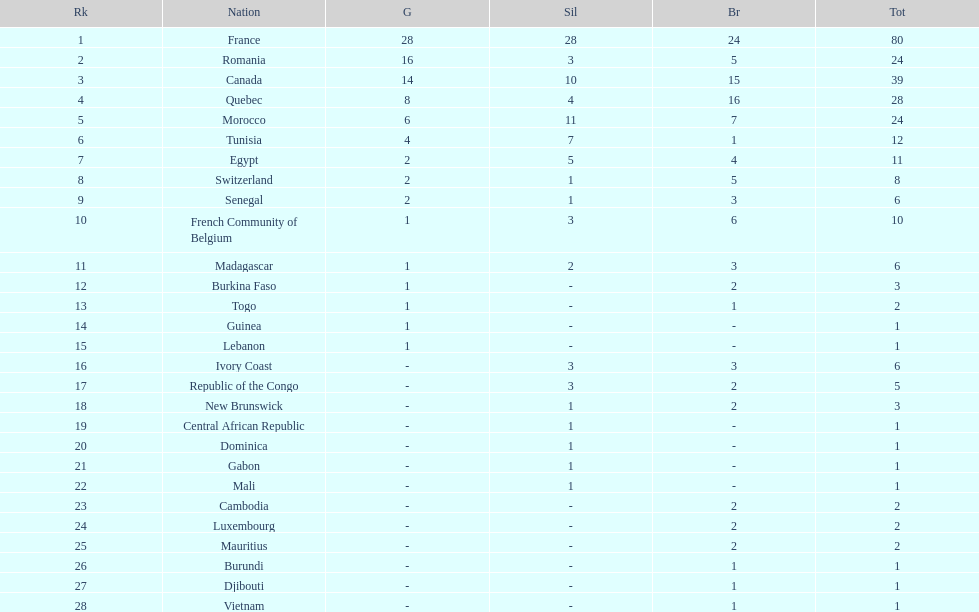How many more medals did egypt win than ivory coast? 5. 